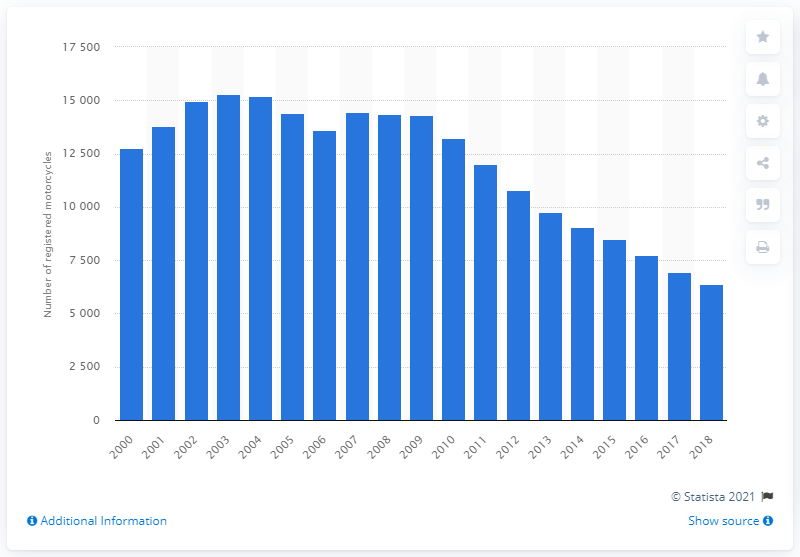Identify some key points in this picture. In 2018, there were 6,388 Kawasaki ZX600 motorcycles registered in Great Britain. In 2000, there were 12,753 Kawasaki ZX600 motorcycles in Great Britain. 